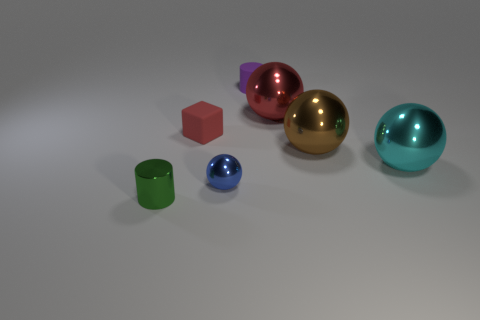Add 2 brown objects. How many objects exist? 9 Subtract all blocks. How many objects are left? 6 Add 5 big red metallic balls. How many big red metallic balls are left? 6 Add 4 big metal objects. How many big metal objects exist? 7 Subtract 0 brown cylinders. How many objects are left? 7 Subtract all red blocks. Subtract all brown balls. How many objects are left? 5 